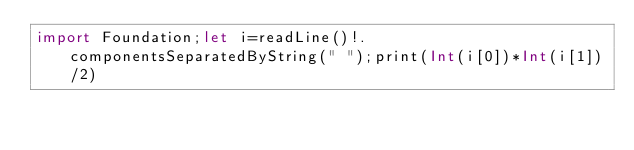Convert code to text. <code><loc_0><loc_0><loc_500><loc_500><_Swift_>import Foundation;let i=readLine()!.componentsSeparatedByString(" ");print(Int(i[0])*Int(i[1])/2)</code> 